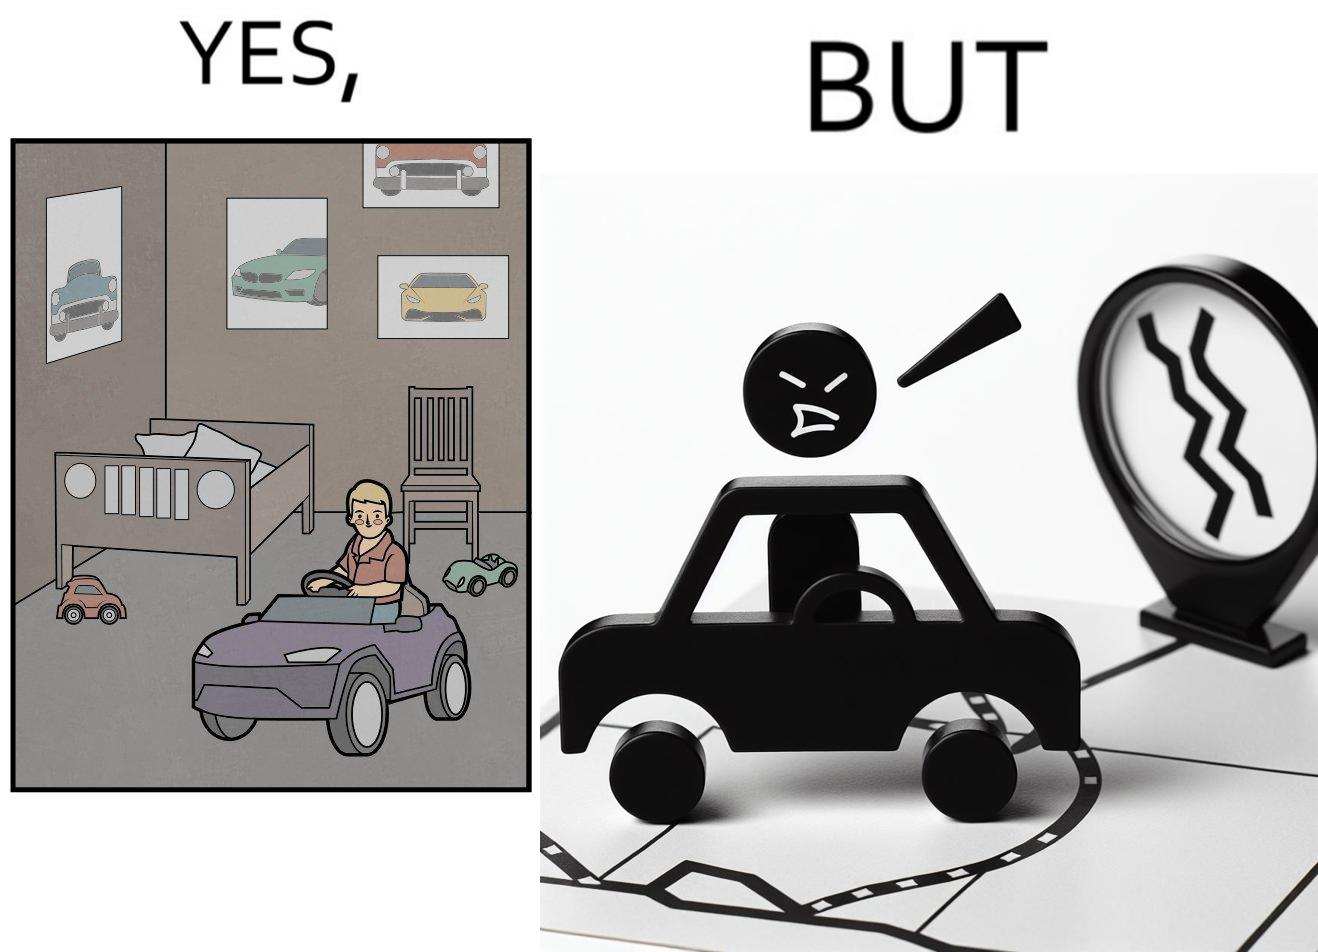Would you classify this image as satirical? Yes, this image is satirical. 